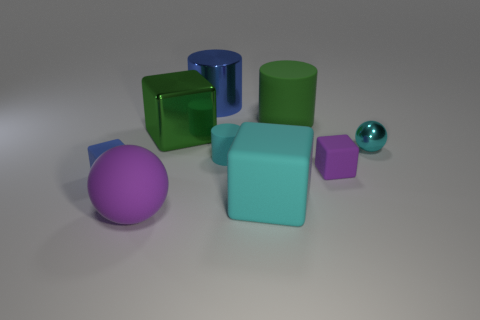Is the large ball the same color as the small matte cylinder?
Your response must be concise. No. What is the color of the matte block on the left side of the large rubber cube?
Your answer should be compact. Blue. What is the shape of the small purple matte object?
Make the answer very short. Cube. There is a small object right of the purple thing behind the small blue rubber thing; is there a large cyan cube behind it?
Offer a terse response. No. What color is the small rubber cube that is behind the matte cube that is on the left side of the big cube in front of the small rubber cylinder?
Ensure brevity in your answer.  Purple. There is a large cyan thing that is the same shape as the small blue thing; what is its material?
Provide a short and direct response. Rubber. How big is the purple matte thing that is to the left of the big metallic object right of the green cube?
Ensure brevity in your answer.  Large. What is the purple thing that is behind the purple matte ball made of?
Your answer should be very brief. Rubber. What is the size of the cyan thing that is made of the same material as the big blue cylinder?
Ensure brevity in your answer.  Small. What number of other large blue shiny objects have the same shape as the large blue shiny thing?
Your response must be concise. 0. 